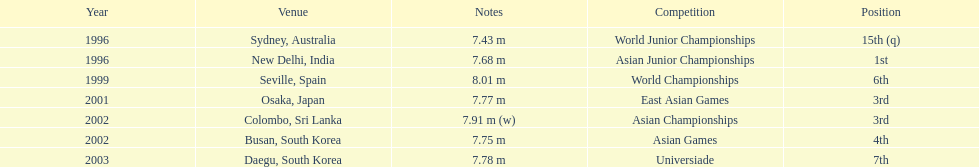What was the only competition where this competitor achieved 1st place? Asian Junior Championships. 